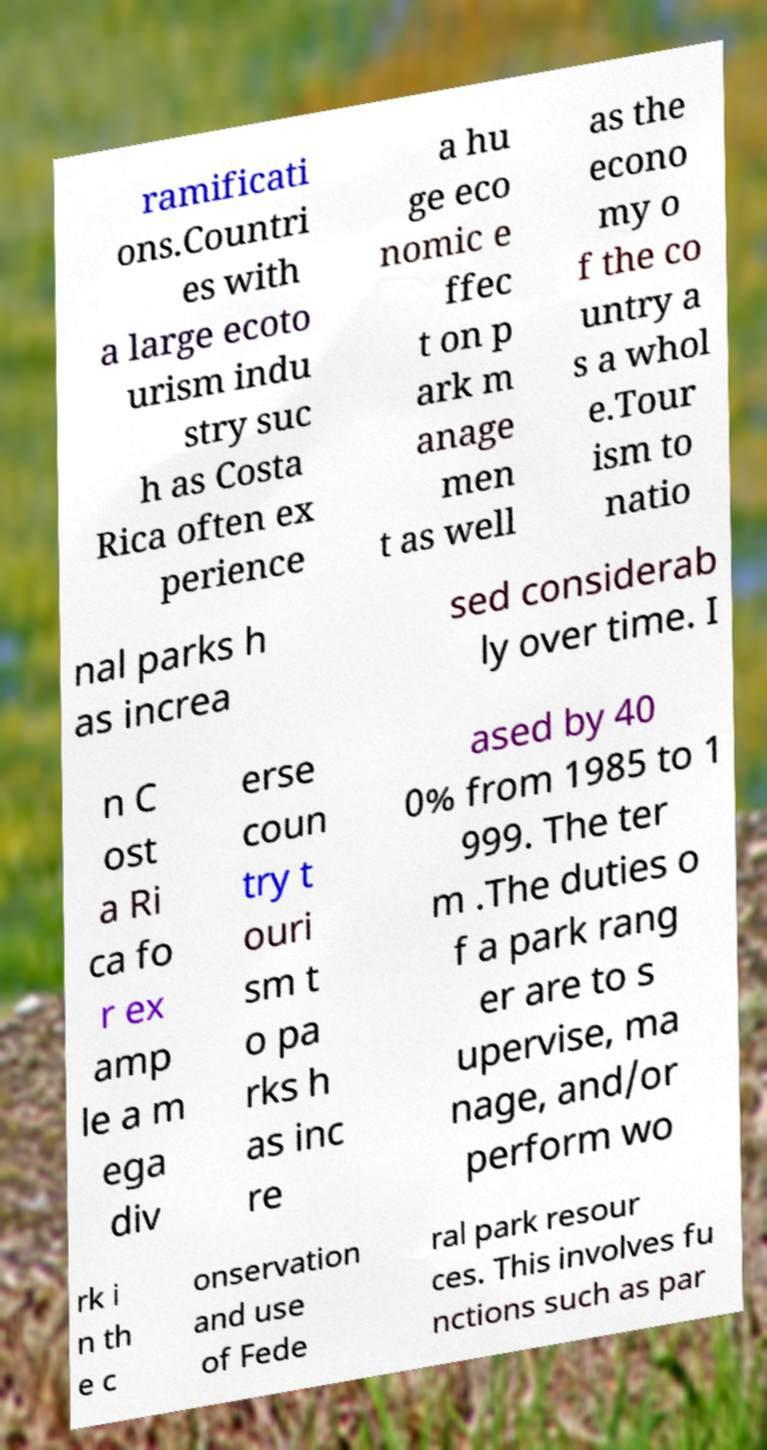Can you accurately transcribe the text from the provided image for me? ramificati ons.Countri es with a large ecoto urism indu stry suc h as Costa Rica often ex perience a hu ge eco nomic e ffec t on p ark m anage men t as well as the econo my o f the co untry a s a whol e.Tour ism to natio nal parks h as increa sed considerab ly over time. I n C ost a Ri ca fo r ex amp le a m ega div erse coun try t ouri sm t o pa rks h as inc re ased by 40 0% from 1985 to 1 999. The ter m .The duties o f a park rang er are to s upervise, ma nage, and/or perform wo rk i n th e c onservation and use of Fede ral park resour ces. This involves fu nctions such as par 